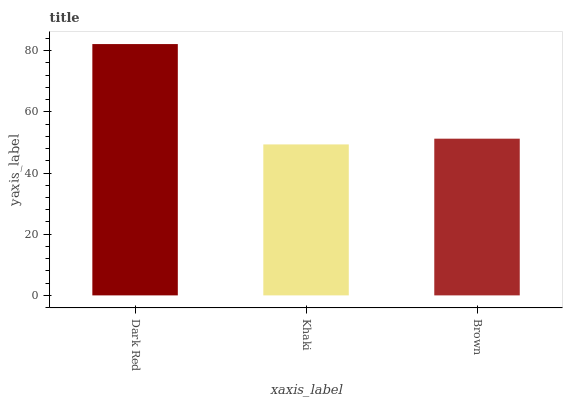Is Khaki the minimum?
Answer yes or no. Yes. Is Dark Red the maximum?
Answer yes or no. Yes. Is Brown the minimum?
Answer yes or no. No. Is Brown the maximum?
Answer yes or no. No. Is Brown greater than Khaki?
Answer yes or no. Yes. Is Khaki less than Brown?
Answer yes or no. Yes. Is Khaki greater than Brown?
Answer yes or no. No. Is Brown less than Khaki?
Answer yes or no. No. Is Brown the high median?
Answer yes or no. Yes. Is Brown the low median?
Answer yes or no. Yes. Is Khaki the high median?
Answer yes or no. No. Is Khaki the low median?
Answer yes or no. No. 